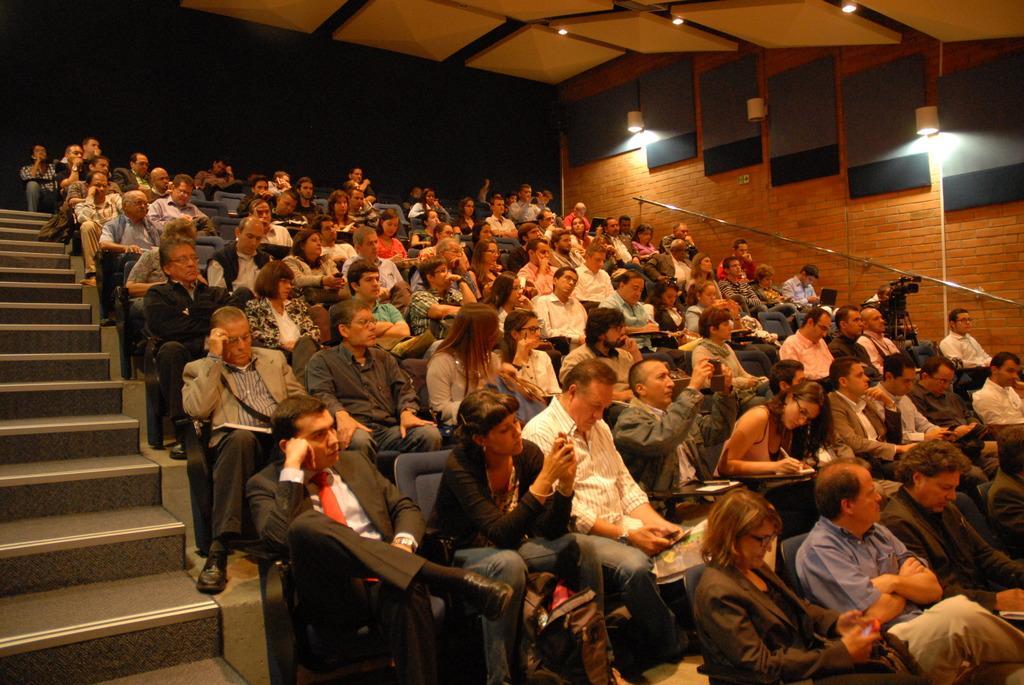Please provide a concise description of this image. In this picture I can see group of people sitting on the chairs and holding some objects. I can see stairs, lights, staircase holder and a camera with a tripod stand. 